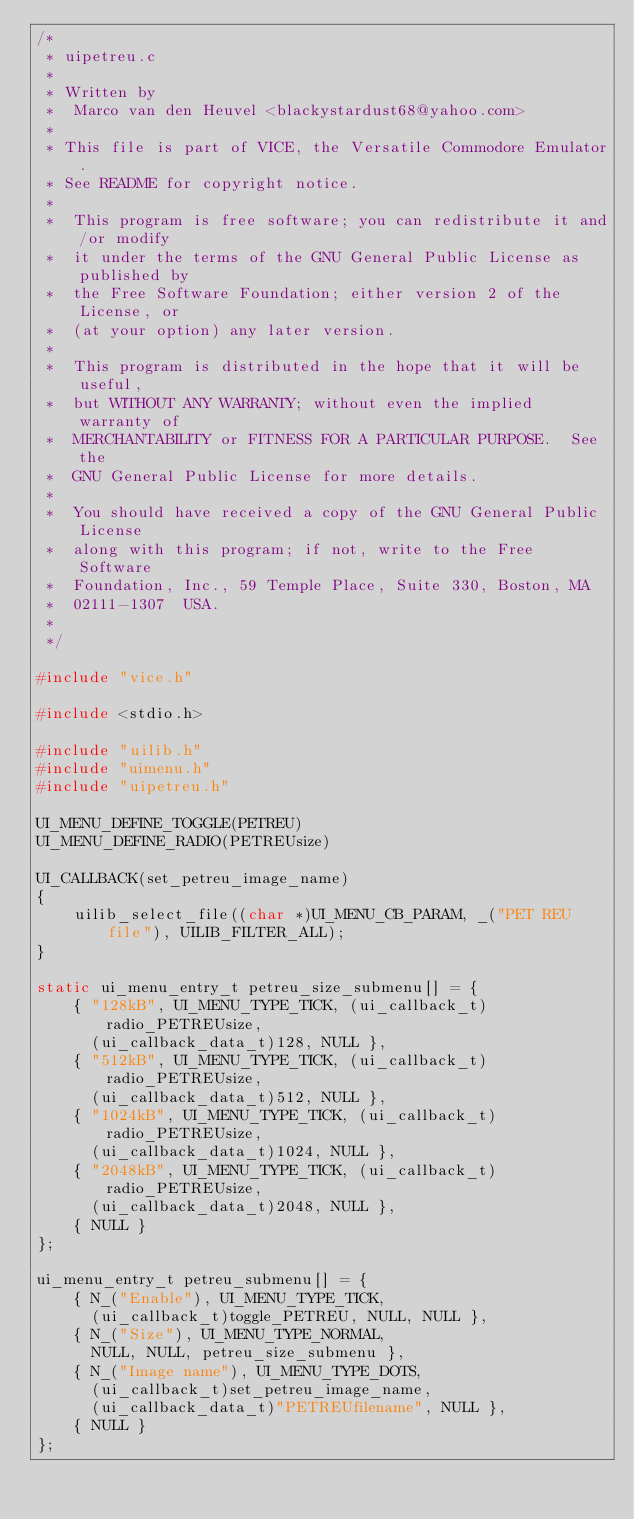<code> <loc_0><loc_0><loc_500><loc_500><_C_>/*
 * uipetreu.c
 *
 * Written by
 *  Marco van den Heuvel <blackystardust68@yahoo.com>
 *
 * This file is part of VICE, the Versatile Commodore Emulator.
 * See README for copyright notice.
 *
 *  This program is free software; you can redistribute it and/or modify
 *  it under the terms of the GNU General Public License as published by
 *  the Free Software Foundation; either version 2 of the License, or
 *  (at your option) any later version.
 *
 *  This program is distributed in the hope that it will be useful,
 *  but WITHOUT ANY WARRANTY; without even the implied warranty of
 *  MERCHANTABILITY or FITNESS FOR A PARTICULAR PURPOSE.  See the
 *  GNU General Public License for more details.
 *
 *  You should have received a copy of the GNU General Public License
 *  along with this program; if not, write to the Free Software
 *  Foundation, Inc., 59 Temple Place, Suite 330, Boston, MA
 *  02111-1307  USA.
 *
 */

#include "vice.h"

#include <stdio.h>

#include "uilib.h"
#include "uimenu.h"
#include "uipetreu.h"

UI_MENU_DEFINE_TOGGLE(PETREU)
UI_MENU_DEFINE_RADIO(PETREUsize)

UI_CALLBACK(set_petreu_image_name)
{
    uilib_select_file((char *)UI_MENU_CB_PARAM, _("PET REU file"), UILIB_FILTER_ALL);
}

static ui_menu_entry_t petreu_size_submenu[] = {
    { "128kB", UI_MENU_TYPE_TICK, (ui_callback_t)radio_PETREUsize,
      (ui_callback_data_t)128, NULL },
    { "512kB", UI_MENU_TYPE_TICK, (ui_callback_t)radio_PETREUsize,
      (ui_callback_data_t)512, NULL },
    { "1024kB", UI_MENU_TYPE_TICK, (ui_callback_t)radio_PETREUsize,
      (ui_callback_data_t)1024, NULL },
    { "2048kB", UI_MENU_TYPE_TICK, (ui_callback_t)radio_PETREUsize,
      (ui_callback_data_t)2048, NULL },
    { NULL }
};

ui_menu_entry_t petreu_submenu[] = {
    { N_("Enable"), UI_MENU_TYPE_TICK,
      (ui_callback_t)toggle_PETREU, NULL, NULL },
    { N_("Size"), UI_MENU_TYPE_NORMAL,
      NULL, NULL, petreu_size_submenu },
    { N_("Image name"), UI_MENU_TYPE_DOTS,
      (ui_callback_t)set_petreu_image_name,
      (ui_callback_data_t)"PETREUfilename", NULL },
    { NULL }
};
</code> 